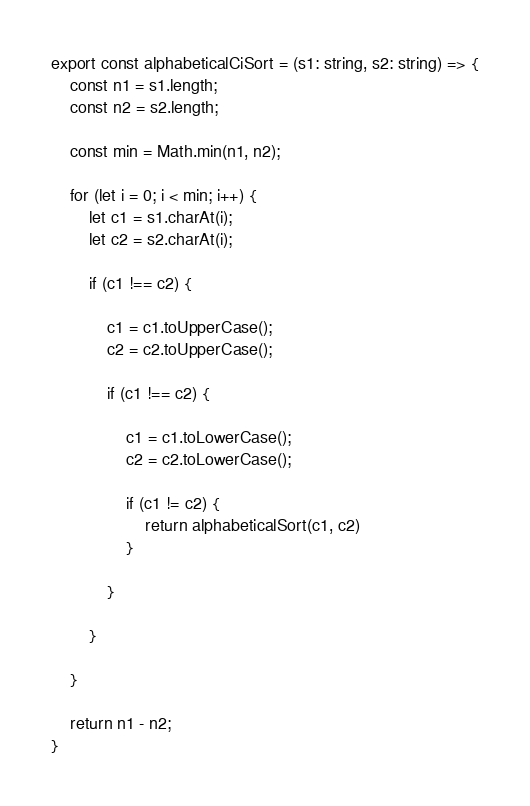Convert code to text. <code><loc_0><loc_0><loc_500><loc_500><_TypeScript_>
export const alphabeticalCiSort = (s1: string, s2: string) => {
    const n1 = s1.length;
    const n2 = s2.length;

    const min = Math.min(n1, n2);

    for (let i = 0; i < min; i++) {
        let c1 = s1.charAt(i);
        let c2 = s2.charAt(i);

        if (c1 !== c2) {

            c1 = c1.toUpperCase();
            c2 = c2.toUpperCase();

            if (c1 !== c2) {

                c1 = c1.toLowerCase();
                c2 = c2.toLowerCase();

                if (c1 != c2) {
                    return alphabeticalSort(c1, c2)
                }

            }

        }

    }

    return n1 - n2;
}
</code> 